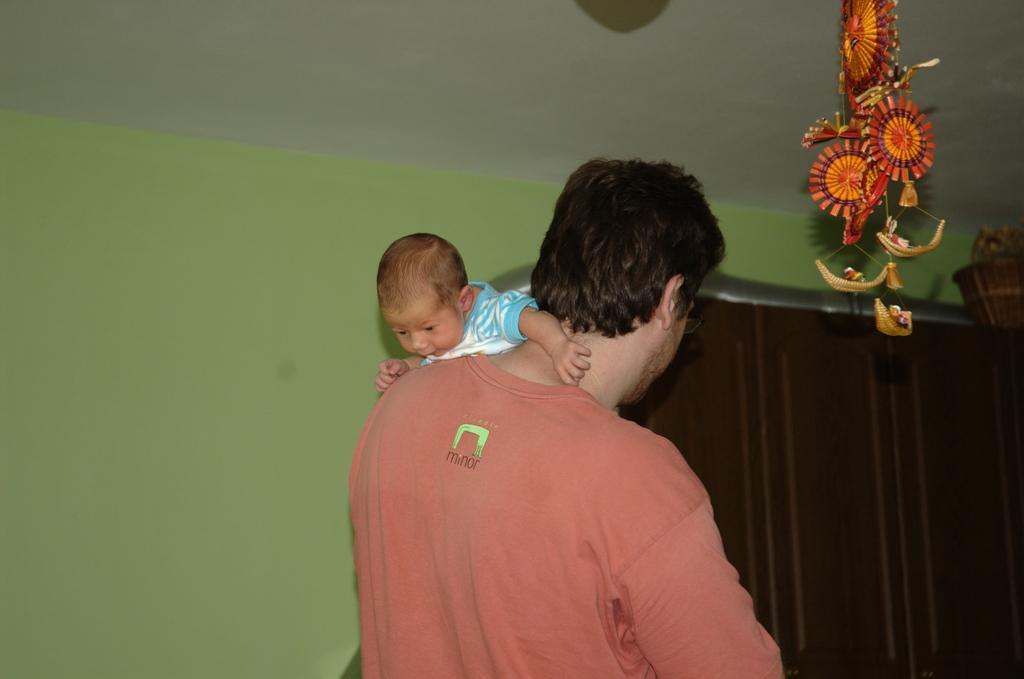What is the man doing in the image? A man is carrying a baby in the image. What can be seen besides the man and the baby? There is a decorative item, a curtain, and a basket in the background. What color is the wall in the background? The wall in the background is green. How much wealth is displayed in the image? There is no indication of wealth in the image; it features a man carrying a baby and various background elements. Can you describe how the baby is shaking in the image? The baby is not shaking in the image; they are being carried by the man. 